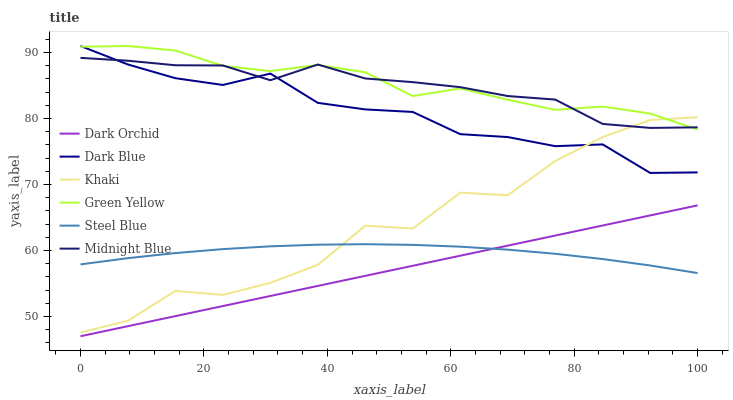Does Dark Orchid have the minimum area under the curve?
Answer yes or no. Yes. Does Green Yellow have the maximum area under the curve?
Answer yes or no. Yes. Does Midnight Blue have the minimum area under the curve?
Answer yes or no. No. Does Midnight Blue have the maximum area under the curve?
Answer yes or no. No. Is Dark Orchid the smoothest?
Answer yes or no. Yes. Is Khaki the roughest?
Answer yes or no. Yes. Is Midnight Blue the smoothest?
Answer yes or no. No. Is Midnight Blue the roughest?
Answer yes or no. No. Does Dark Orchid have the lowest value?
Answer yes or no. Yes. Does Steel Blue have the lowest value?
Answer yes or no. No. Does Green Yellow have the highest value?
Answer yes or no. Yes. Does Midnight Blue have the highest value?
Answer yes or no. No. Is Dark Orchid less than Midnight Blue?
Answer yes or no. Yes. Is Dark Blue greater than Steel Blue?
Answer yes or no. Yes. Does Khaki intersect Midnight Blue?
Answer yes or no. Yes. Is Khaki less than Midnight Blue?
Answer yes or no. No. Is Khaki greater than Midnight Blue?
Answer yes or no. No. Does Dark Orchid intersect Midnight Blue?
Answer yes or no. No. 